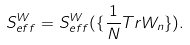Convert formula to latex. <formula><loc_0><loc_0><loc_500><loc_500>S ^ { W } _ { e f f } = S ^ { W } _ { e f f } ( \{ \frac { 1 } { N } T r W _ { n } \} ) .</formula> 